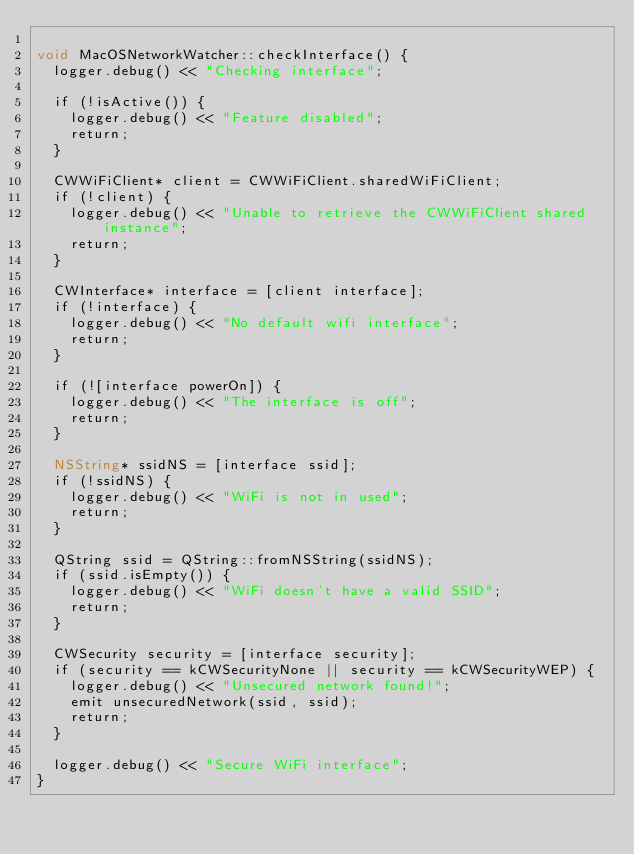Convert code to text. <code><loc_0><loc_0><loc_500><loc_500><_ObjectiveC_>
void MacOSNetworkWatcher::checkInterface() {
  logger.debug() << "Checking interface";

  if (!isActive()) {
    logger.debug() << "Feature disabled";
    return;
  }

  CWWiFiClient* client = CWWiFiClient.sharedWiFiClient;
  if (!client) {
    logger.debug() << "Unable to retrieve the CWWiFiClient shared instance";
    return;
  }

  CWInterface* interface = [client interface];
  if (!interface) {
    logger.debug() << "No default wifi interface";
    return;
  }

  if (![interface powerOn]) {
    logger.debug() << "The interface is off";
    return;
  }

  NSString* ssidNS = [interface ssid];
  if (!ssidNS) {
    logger.debug() << "WiFi is not in used";
    return;
  }

  QString ssid = QString::fromNSString(ssidNS);
  if (ssid.isEmpty()) {
    logger.debug() << "WiFi doesn't have a valid SSID";
    return;
  }

  CWSecurity security = [interface security];
  if (security == kCWSecurityNone || security == kCWSecurityWEP) {
    logger.debug() << "Unsecured network found!";
    emit unsecuredNetwork(ssid, ssid);
    return;
  }

  logger.debug() << "Secure WiFi interface";
}
</code> 